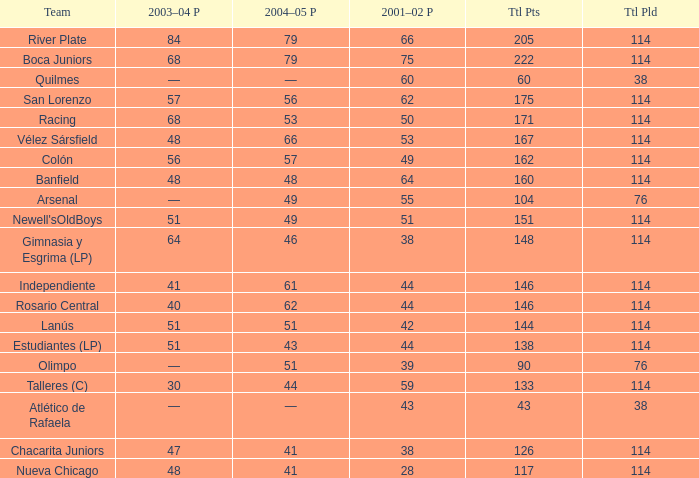Which Total Pts have a 2001–02 Pts smaller than 38? 117.0. 